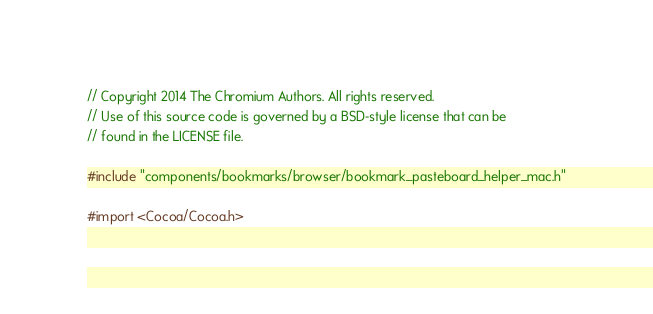Convert code to text. <code><loc_0><loc_0><loc_500><loc_500><_ObjectiveC_>// Copyright 2014 The Chromium Authors. All rights reserved.
// Use of this source code is governed by a BSD-style license that can be
// found in the LICENSE file.

#include "components/bookmarks/browser/bookmark_pasteboard_helper_mac.h"

#import <Cocoa/Cocoa.h></code> 